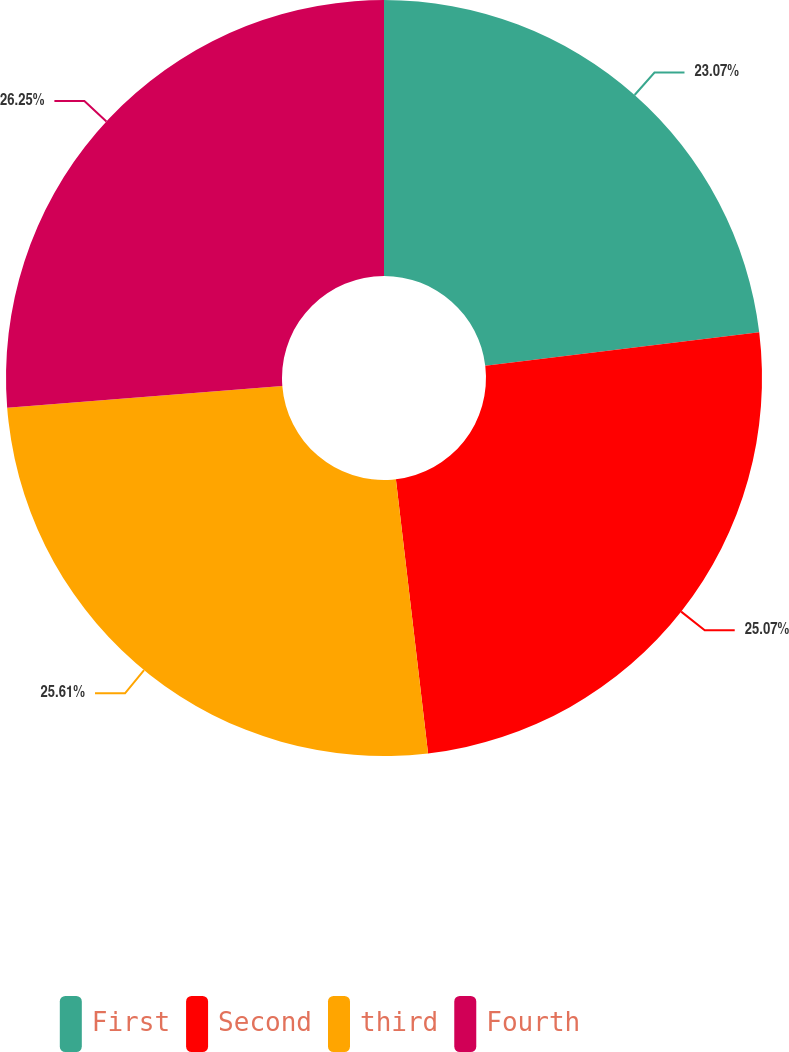<chart> <loc_0><loc_0><loc_500><loc_500><pie_chart><fcel>First<fcel>Second<fcel>third<fcel>Fourth<nl><fcel>23.07%<fcel>25.07%<fcel>25.61%<fcel>26.25%<nl></chart> 